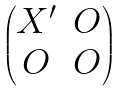<formula> <loc_0><loc_0><loc_500><loc_500>\begin{pmatrix} X ^ { \prime } & O \\ O & O \end{pmatrix}</formula> 